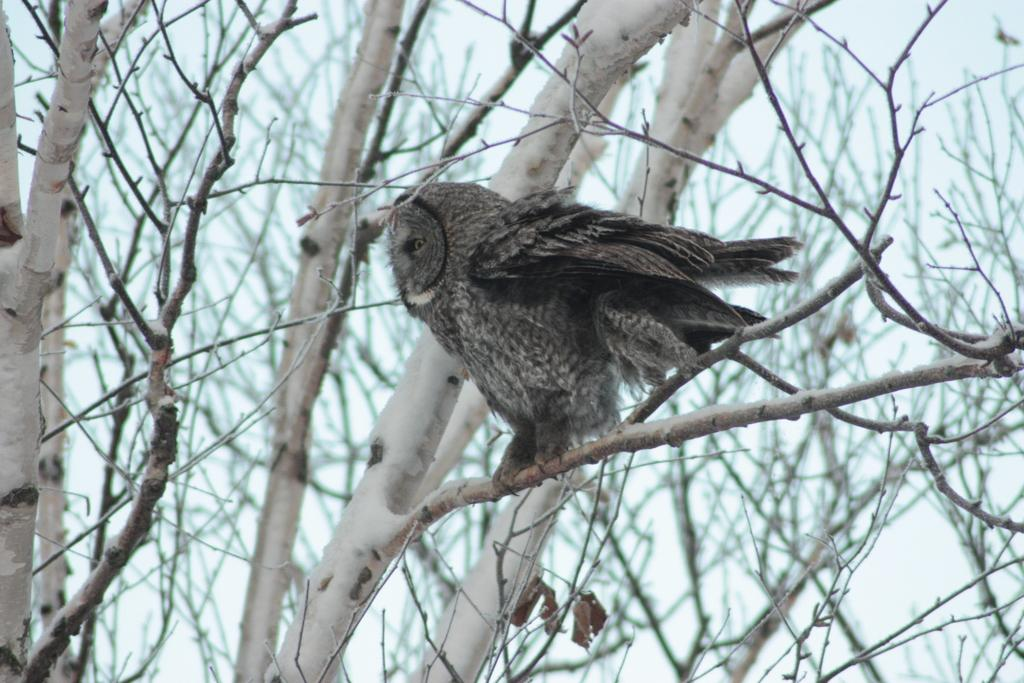What type of vegetation can be seen in the image? There are trees in the image. What animal is present in the image? There is an owl in the image. Where is the owl located in relation to the image? The owl is in the front of the image. What can be seen in the background of the image? The sky is visible in the background of the image. What type of spark can be seen coming from the owl's eyes in the image? There is no spark coming from the owl's eyes in the image; the owl is simply sitting in the front of the image. How many houses are visible in the image? There are no houses present in the image; it features trees, an owl, and the sky. 